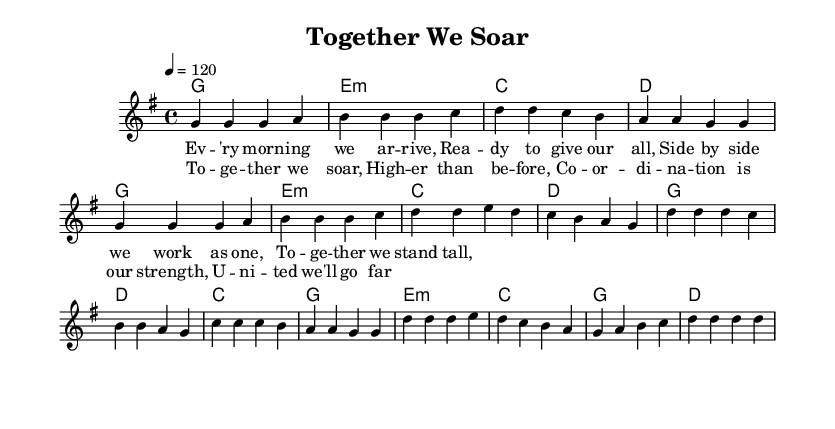What is the key signature of this music? The key signature is G major, which has one sharp (F#). This is indicated at the beginning of the sheet music under the clef sign.
Answer: G major What is the time signature of this music? The time signature is 4/4, which is visible at the beginning of the score. This means there are four beats in each measure and a quarter note gets one beat.
Answer: 4/4 What is the tempo marking indicated in the score? The tempo marking is 120 beats per minute, shown at the beginning of the score as “\tempo 4 = 120”. This indicates the speed of the piece.
Answer: 120 How many measures are in the verse section? The verse section consists of 8 measures, as can be counted by looking at the musical notation in the melody part below the lyrics.
Answer: 8 Which chord appears most frequently in the verse? The G major chord appears most frequently in the verse, being played in the first, fifth, and following all measures as the primary harmony.
Answer: G What is the function of the chorus in this piece? The chorus acts as the main thematic statement, emphasizing the message of teamwork and coordination, which reinforces the overall meaning of the song about unity. The repetition and melody contribute to this role.
Answer: Main thematic statement How many distinct lines of lyrics are provided for the chorus? There are two distinct lines of lyrics provided for the chorus, which are used to express the key ideas of the song about soaring together and the importance of coordination.
Answer: 2 